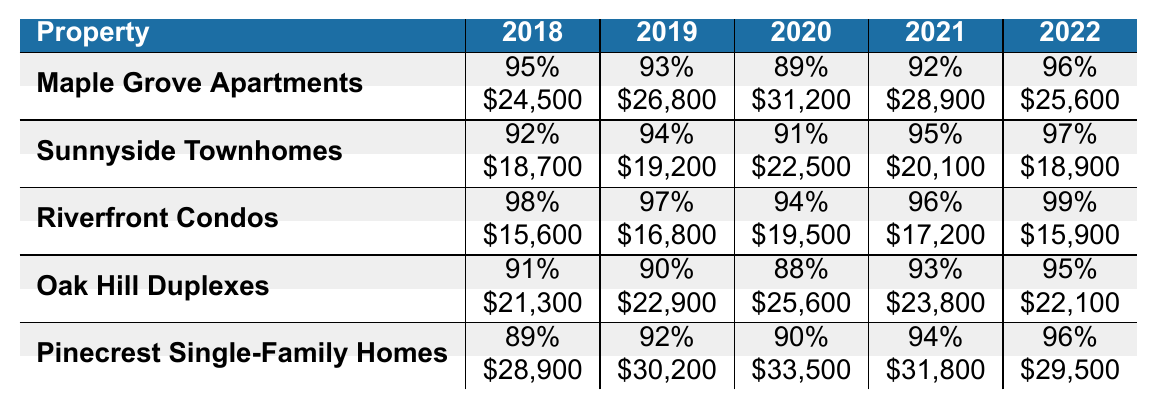What was the occupancy rate for Riverfront Condos in 2020? From the table, the occupancy rate for Riverfront Condos in 2020 is found in the corresponding row for that property and year, indicated as 94%.
Answer: 94% What are the maintenance costs for Oak Hill Duplexes in 2021? By checking the row for Oak Hill Duplexes under the year 2021, the maintenance cost is listed as $23,800.
Answer: $23,800 Which property had the lowest occupancy rate in 2019? Reviewing the occupancy rates for all properties in 2019: Maple Grove (93%), Sunnyside (94%), Riverfront (97%), Oak Hill (90%), and Pinecrest (92%). Oak Hill Duplexes had the lowest at 90%.
Answer: Oak Hill Duplexes What was the average occupancy rate for Pinecrest Single-Family Homes over the five years? The occupancy rates for Pinecrest are 89%, 92%, 90%, 94%, and 96%. Adding these rates gives 89 + 92 + 90 + 94 + 96 = 461; dividing by 5 results in an average of 92.2%.
Answer: 92.2% Did the maintenance costs for Riverfront Condos increase every year from 2018 to 2022? Assessing the maintenance costs for Riverfront Condos: 15,600 (2018), 16,800 (2019), 19,500 (2020), 17,200 (2021), and 15,900 (2022). The costs decreased from 2020 to 2021 and again from 2021 to 2022, so the statement is false.
Answer: No What is the total maintenance cost for all properties in 2020? Summing the maintenance costs for all properties in 2020: 31,200 (Maple Grove) + 22,500 (Sunnyside) + 19,500 (Riverfront) + 25,600 (Oak Hill) + 33,500 (Pinecrest) gives a total of 132,300.
Answer: $132,300 Which year did Sunnyside Townhomes have the highest occupancy rate? Looking at the occupancy rates for Sunnyside Townhomes, the rates for 2018, 2019, 2020, 2021, and 2022 are 92%, 94%, 91%, 95%, and 97%, respectively. The highest rate is 97% in 2022.
Answer: 2022 What is the difference in maintenance costs between Maple Grove Apartments and Pinecrest Single-Family Homes in 2022? The maintenance costs for Maple Grove in 2022 is $25,600, and for Pinecrest, it is $29,500. The difference is calculated as $29,500 - $25,600 = $3,900.
Answer: $3,900 In which property did the maintenance costs fluctuate the most over the 5 years? Analyzing the maintenance costs for each property, Pinecrest had costs of $28,900, $30,200, $33,500, $31,800, and $29,500, with a fluctuation of $4,600. Comparing all properties, Pinecrest had the highest fluctuation.
Answer: Pinecrest Single-Family Homes 